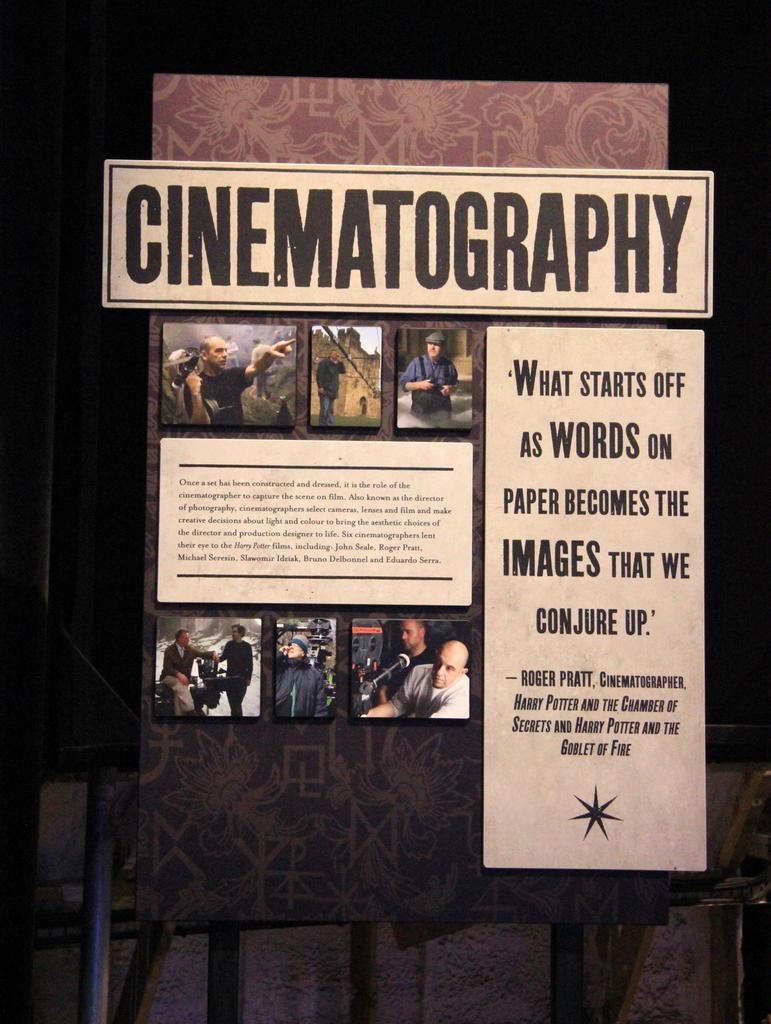<image>
Relay a brief, clear account of the picture shown. A display with photos and text talks about cinematography. 